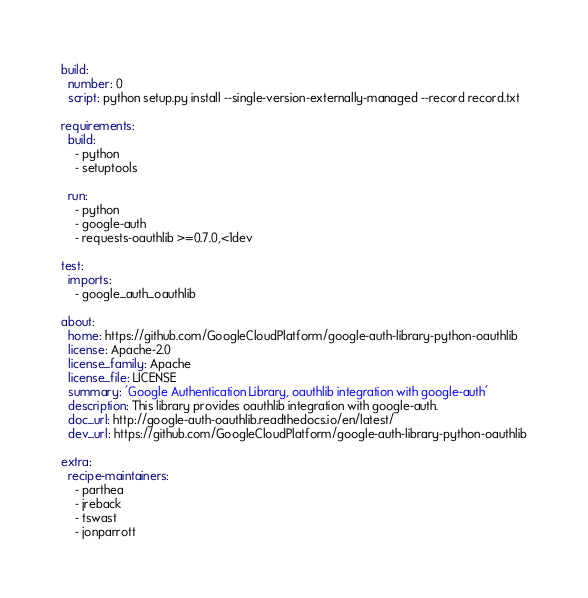<code> <loc_0><loc_0><loc_500><loc_500><_YAML_>build:
  number: 0
  script: python setup.py install --single-version-externally-managed --record record.txt

requirements:
  build:
    - python
    - setuptools

  run:
    - python
    - google-auth
    - requests-oauthlib >=0.7.0,<1dev

test:
  imports:
    - google_auth_oauthlib

about:
  home: https://github.com/GoogleCloudPlatform/google-auth-library-python-oauthlib
  license: Apache-2.0
  license_family: Apache
  license_file: LICENSE
  summary: 'Google Authentication Library, oauthlib integration with google-auth'
  description: This library provides oauthlib integration with google-auth.
  doc_url: http://google-auth-oauthlib.readthedocs.io/en/latest/
  dev_url: https://github.com/GoogleCloudPlatform/google-auth-library-python-oauthlib

extra:
  recipe-maintainers:
    - parthea
    - jreback
    - tswast
    - jonparrott
</code> 